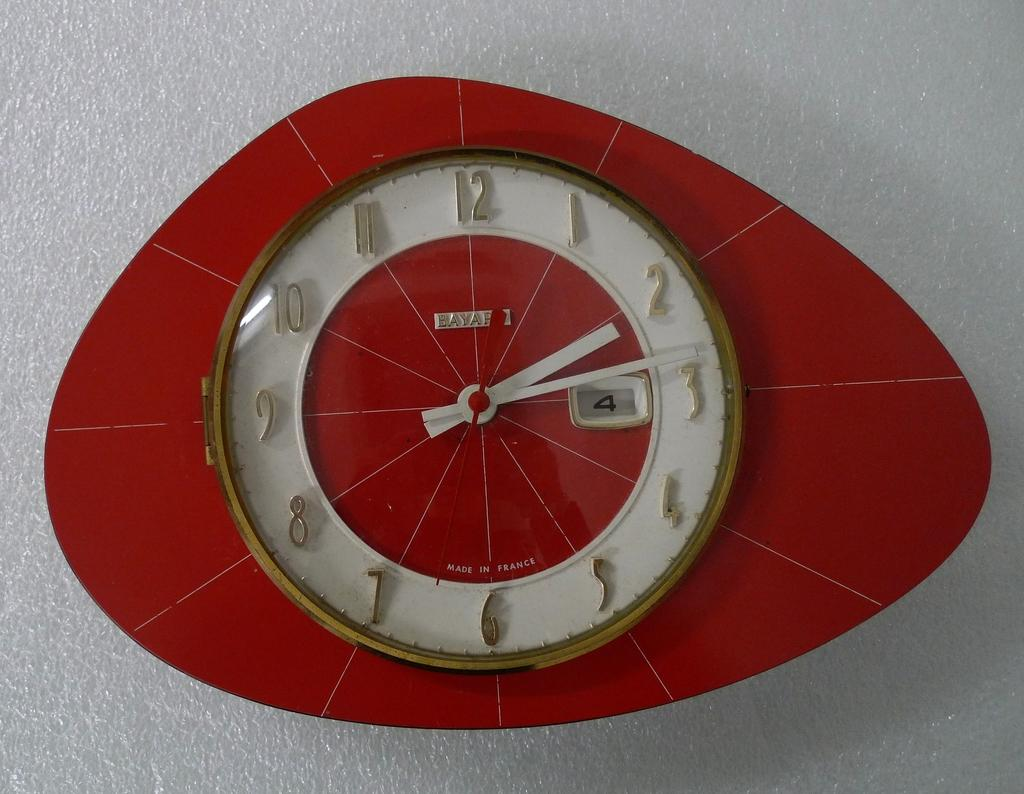<image>
Give a short and clear explanation of the subsequent image. A red clock reads that it was "made in France." 